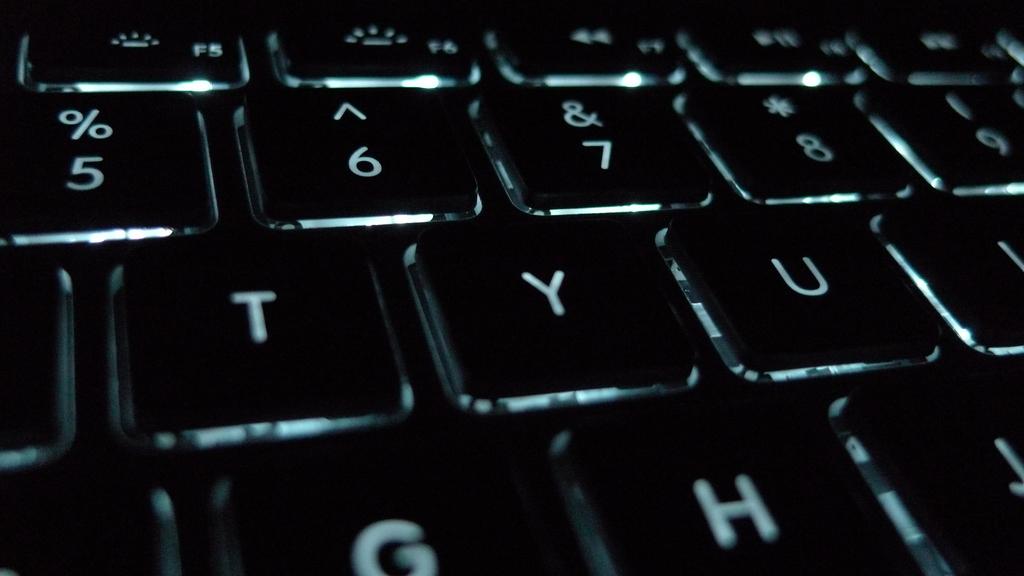What keys are showing?
Make the answer very short. 56789tyugh. 